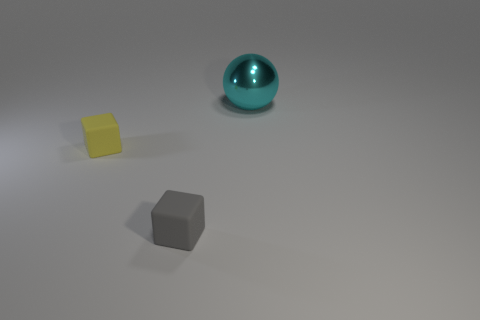Is the size of the metal ball the same as the thing that is on the left side of the tiny gray matte cube? no 